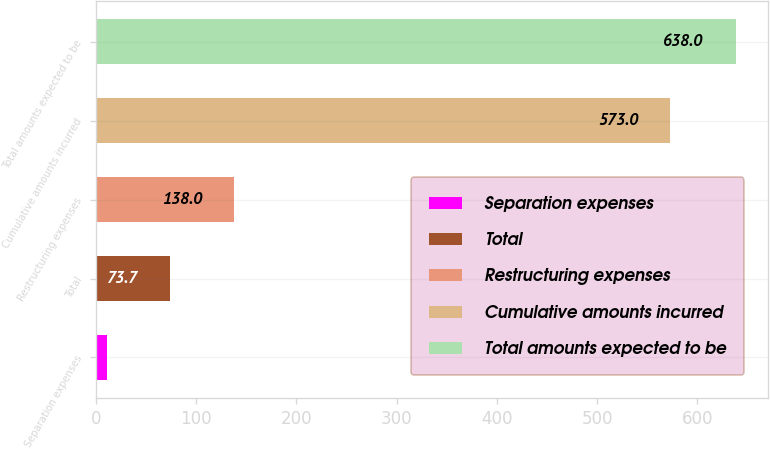Convert chart to OTSL. <chart><loc_0><loc_0><loc_500><loc_500><bar_chart><fcel>Separation expenses<fcel>Total<fcel>Restructuring expenses<fcel>Cumulative amounts incurred<fcel>Total amounts expected to be<nl><fcel>11<fcel>73.7<fcel>138<fcel>573<fcel>638<nl></chart> 